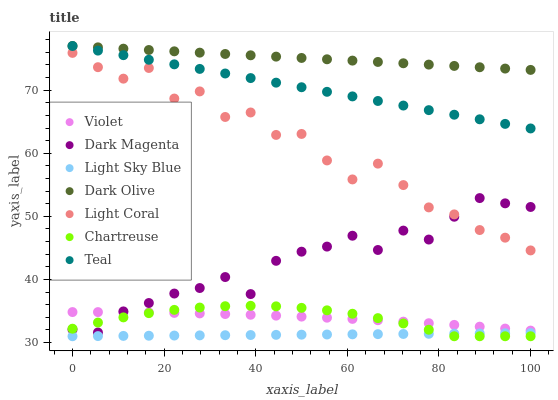Does Light Sky Blue have the minimum area under the curve?
Answer yes or no. Yes. Does Dark Olive have the maximum area under the curve?
Answer yes or no. Yes. Does Light Coral have the minimum area under the curve?
Answer yes or no. No. Does Light Coral have the maximum area under the curve?
Answer yes or no. No. Is Light Sky Blue the smoothest?
Answer yes or no. Yes. Is Light Coral the roughest?
Answer yes or no. Yes. Is Dark Olive the smoothest?
Answer yes or no. No. Is Dark Olive the roughest?
Answer yes or no. No. Does Chartreuse have the lowest value?
Answer yes or no. Yes. Does Light Coral have the lowest value?
Answer yes or no. No. Does Teal have the highest value?
Answer yes or no. Yes. Does Light Coral have the highest value?
Answer yes or no. No. Is Light Sky Blue less than Dark Magenta?
Answer yes or no. Yes. Is Light Coral greater than Chartreuse?
Answer yes or no. Yes. Does Chartreuse intersect Violet?
Answer yes or no. Yes. Is Chartreuse less than Violet?
Answer yes or no. No. Is Chartreuse greater than Violet?
Answer yes or no. No. Does Light Sky Blue intersect Dark Magenta?
Answer yes or no. No. 